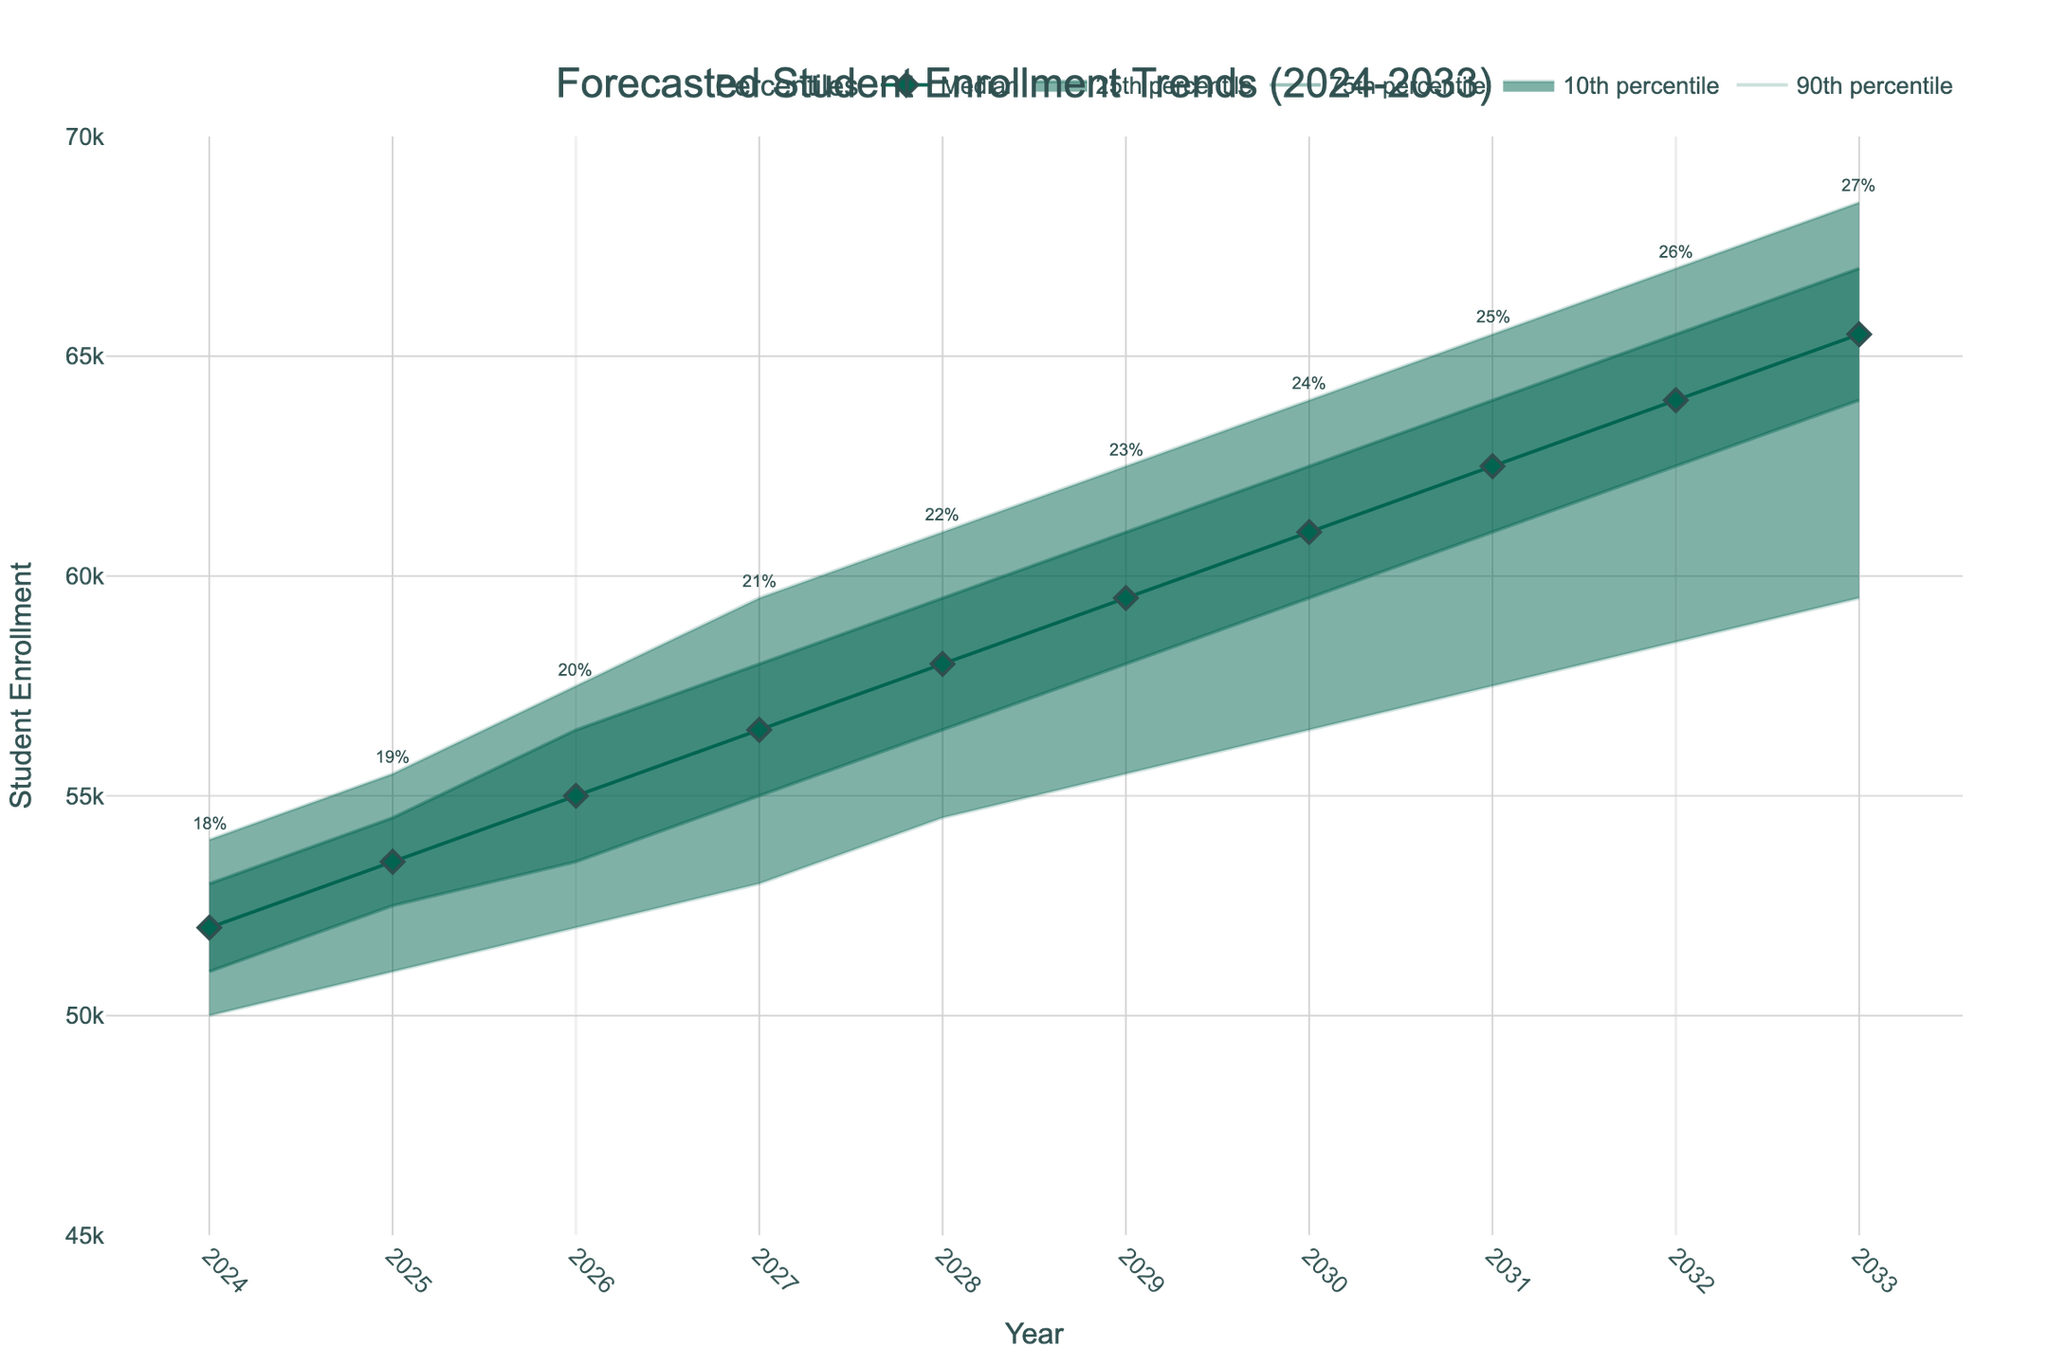What is the title of the figure? The title is usually prominently displayed at the top of the figure. It provides a concise description of the figure's content. In this case, it reads "Forecasted Student Enrollment Trends (2024-2033)"
Answer: Forecasted Student Enrollment Trends (2024-2033) What is the forecasted median student enrollment in 2028? By locating the year 2028 along the x-axis and referring to the median line (a solid line with diamond markers), we can find the median student enrollment value for that year.
Answer: 58,000 How does the upper 90th percentile in 2033 compare to the upper 90th percentile in 2024? To answer, identify the y-values for the 90th percentile in both 2033 and 2024 along the respective lines. The value in 2033 is 68,500 and in 2024 is 54,000, showing an increase.
Answer: It increases from 54,000 to 68,500 What is the percentage ratio of international students expected by 2031? Each data point for the upper 90th percentile has an annotation indicating the international student ratio. For 2031, the annotation shows 25%.
Answer: 25% How does the median enrollment change from 2024 to 2030? Check the median values for 2024 and 2030 on the median line. The median in 2024 is 52,000 and in 2030 is 61,000. The change is calculated as 61,000 - 52,000.
Answer: It increases by 9,000 What is the range of student enrollments (from 10th percentile to 90th percentile) forecasted for 2025? Locate the lower 10th and upper 90th percentile values for 2025. The 10th percentile is 51,000, and the 90th percentile is 55,500. The range is 55,500 - 51,000.
Answer: 4,500 What trend is observed in the international student ratio from 2024 to 2033? Review the annotations indicating the international student ratio for each year from 2024 to 2033. The ratios increase steadily each year, from 18% in 2024 to 27% in 2033.
Answer: Increasing trend By how much does the 75th percentile value in 2029 exceed the median value in the same year? Find the 75th percentile and median values for 2029. The 75th percentile is 61,000 and the median is 59,500. The difference is 61,000 - 59,500.
Answer: 1,500 Compare the lower 25th percentile in 2027 with the median in 2026. Which is higher, and by how much? Identify the lower 25th percentile for 2027 (55,000) and the median for 2026 (55,000). Both values are equal.
Answer: They are equal What can you infer about the uncertainty of the enrollment forecast over the years? Examining the increasing spread between the lower 10th and upper 90th percentile lines from 2024 to 2033 suggests growing uncertainty in the forecast over time.
Answer: Growing uncertainty 